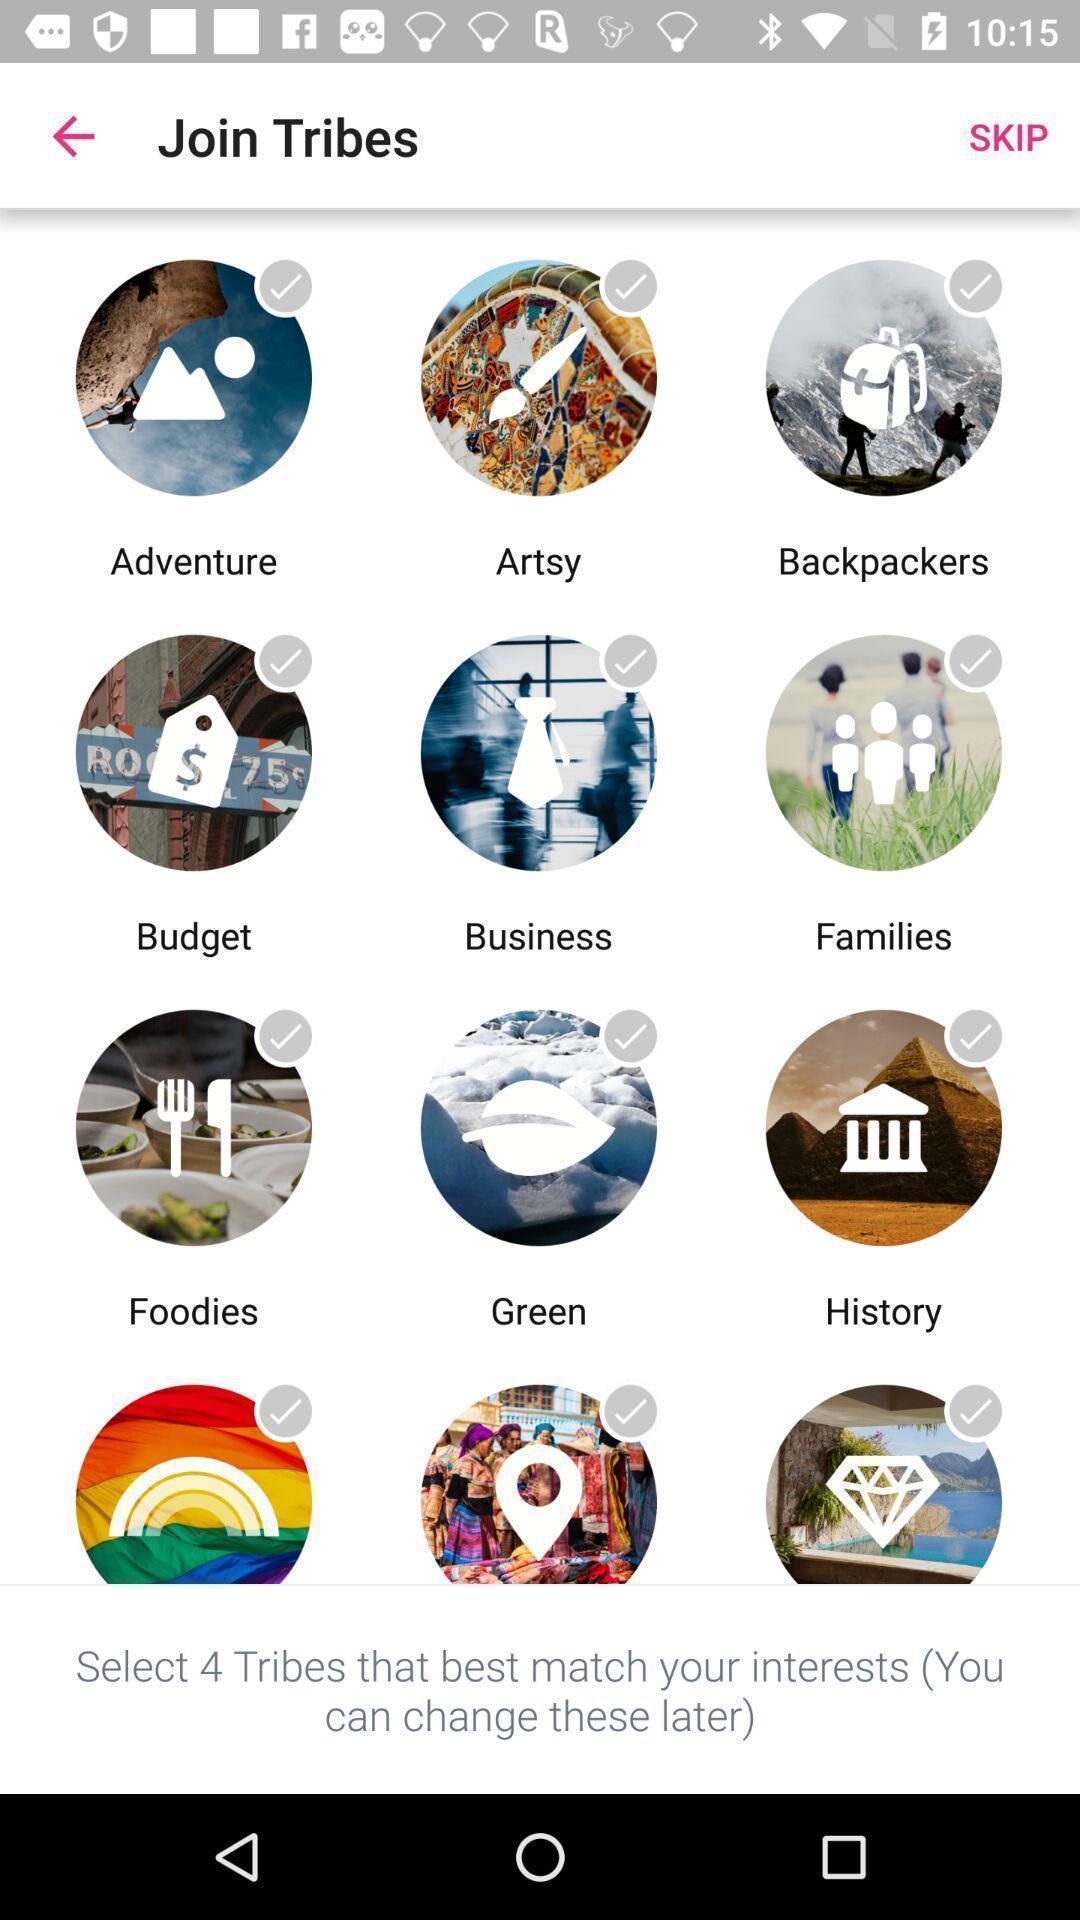Summarize the information in this screenshot. Page showing different icons and options. 